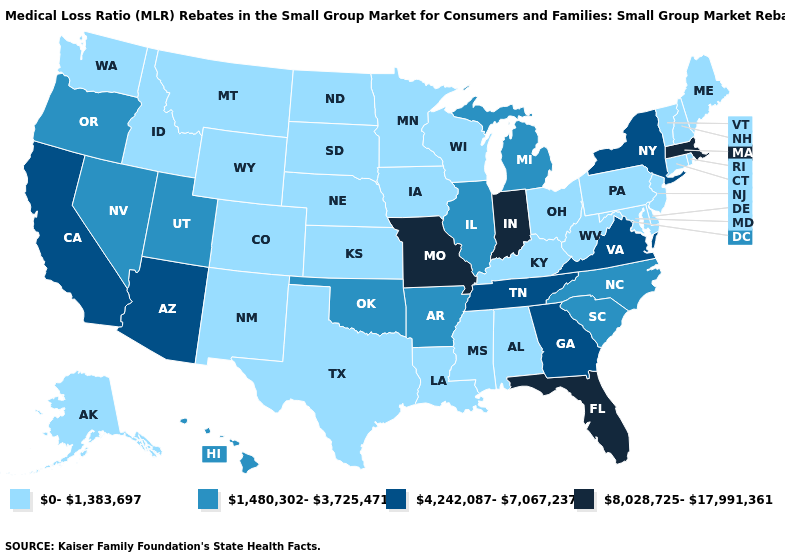What is the value of Arkansas?
Keep it brief. 1,480,302-3,725,471. What is the value of Florida?
Quick response, please. 8,028,725-17,991,361. Which states hav the highest value in the Northeast?
Keep it brief. Massachusetts. Does Idaho have the lowest value in the West?
Short answer required. Yes. Which states have the lowest value in the USA?
Give a very brief answer. Alabama, Alaska, Colorado, Connecticut, Delaware, Idaho, Iowa, Kansas, Kentucky, Louisiana, Maine, Maryland, Minnesota, Mississippi, Montana, Nebraska, New Hampshire, New Jersey, New Mexico, North Dakota, Ohio, Pennsylvania, Rhode Island, South Dakota, Texas, Vermont, Washington, West Virginia, Wisconsin, Wyoming. What is the highest value in states that border Ohio?
Write a very short answer. 8,028,725-17,991,361. Does Missouri have the highest value in the USA?
Concise answer only. Yes. What is the lowest value in the South?
Keep it brief. 0-1,383,697. Name the states that have a value in the range 4,242,087-7,067,237?
Write a very short answer. Arizona, California, Georgia, New York, Tennessee, Virginia. Among the states that border Michigan , does Wisconsin have the highest value?
Concise answer only. No. Which states have the lowest value in the West?
Concise answer only. Alaska, Colorado, Idaho, Montana, New Mexico, Washington, Wyoming. Does Indiana have the highest value in the USA?
Answer briefly. Yes. Does Kansas have a lower value than Alaska?
Be succinct. No. Does the first symbol in the legend represent the smallest category?
Short answer required. Yes. How many symbols are there in the legend?
Concise answer only. 4. 